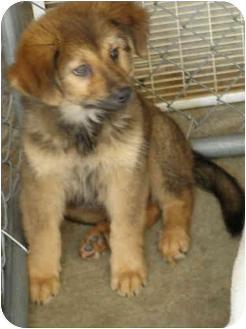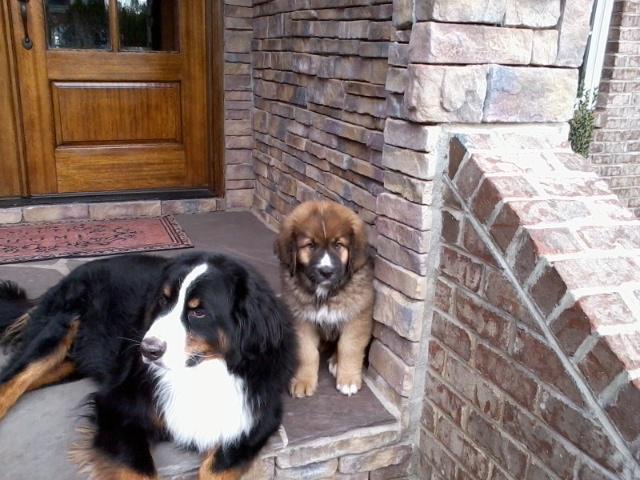The first image is the image on the left, the second image is the image on the right. Analyze the images presented: Is the assertion "There are three dogs" valid? Answer yes or no. Yes. 